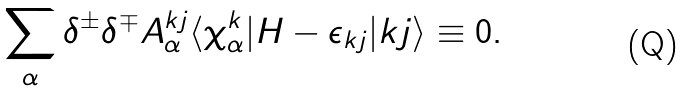Convert formula to latex. <formula><loc_0><loc_0><loc_500><loc_500>\sum _ { \alpha } \delta ^ { \pm } \delta ^ { \mp } A _ { \alpha } ^ { { k } j } \langle \chi _ { \alpha } ^ { k } | H - \epsilon _ { { k } j } | { k } j \rangle \equiv 0 .</formula> 